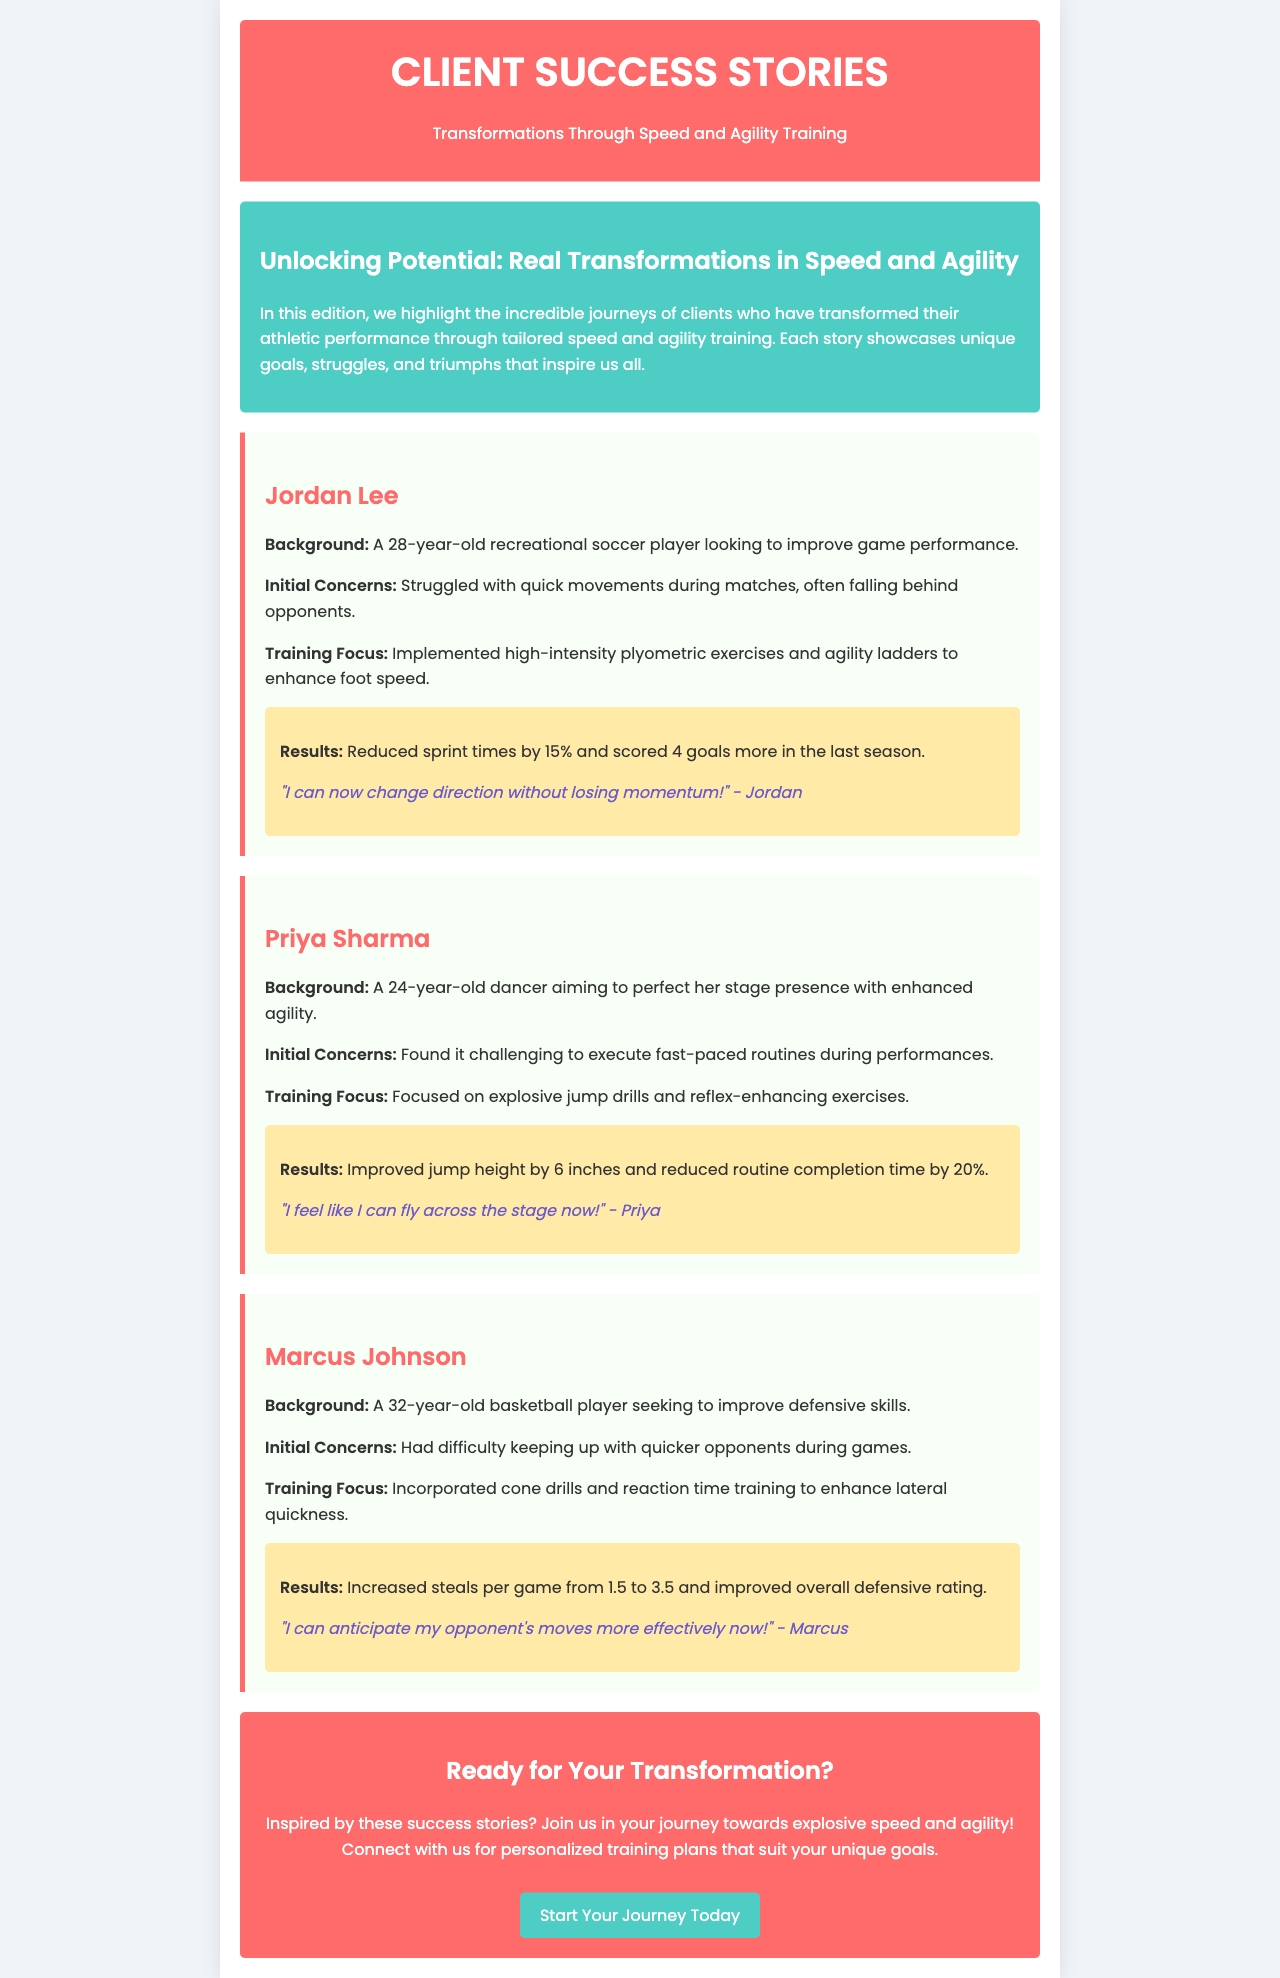What is the title of the newsletter? The title of the newsletter is given in the header section of the document.
Answer: Client Success Stories Who is the first client featured in the success stories? The name of the first client is found in the success story section.
Answer: Jordan Lee What was Jordan Lee's initial concern? Jordan Lee's initial concern is stated in his success story section.
Answer: Struggled with quick movements during matches How much did Priya Sharma improve her jump height? Priya Sharma's improvement in jump height is included in the results section of her story.
Answer: 6 inches What training focus did Marcus Johnson incorporate? The training focus for Marcus Johnson is noted in the relevant section of his success story.
Answer: Incorporated cone drills and reaction time training How many goals did Jordan Lee score more in the last season? The increase in goals scored by Jordan Lee is mentioned in the results of his section.
Answer: 4 goals What color is the background of the introduction section? The background color of the introduction section is described within the style definitions.
Answer: #4ecdc4 How many steals per game did Marcus Johnson increase from? The increase in steals per game for Marcus Johnson is found in his results section comparing two statistics.
Answer: 1.5 to 3.5 What is the main call to action in the conclusion? The call to action is specified at the end of the newsletter to encourage readers.
Answer: Start Your Journey Today 